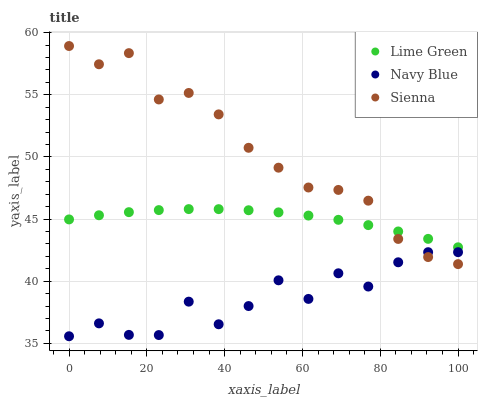Does Navy Blue have the minimum area under the curve?
Answer yes or no. Yes. Does Sienna have the maximum area under the curve?
Answer yes or no. Yes. Does Lime Green have the minimum area under the curve?
Answer yes or no. No. Does Lime Green have the maximum area under the curve?
Answer yes or no. No. Is Lime Green the smoothest?
Answer yes or no. Yes. Is Navy Blue the roughest?
Answer yes or no. Yes. Is Navy Blue the smoothest?
Answer yes or no. No. Is Lime Green the roughest?
Answer yes or no. No. Does Navy Blue have the lowest value?
Answer yes or no. Yes. Does Lime Green have the lowest value?
Answer yes or no. No. Does Sienna have the highest value?
Answer yes or no. Yes. Does Lime Green have the highest value?
Answer yes or no. No. Is Navy Blue less than Lime Green?
Answer yes or no. Yes. Is Lime Green greater than Navy Blue?
Answer yes or no. Yes. Does Sienna intersect Navy Blue?
Answer yes or no. Yes. Is Sienna less than Navy Blue?
Answer yes or no. No. Is Sienna greater than Navy Blue?
Answer yes or no. No. Does Navy Blue intersect Lime Green?
Answer yes or no. No. 